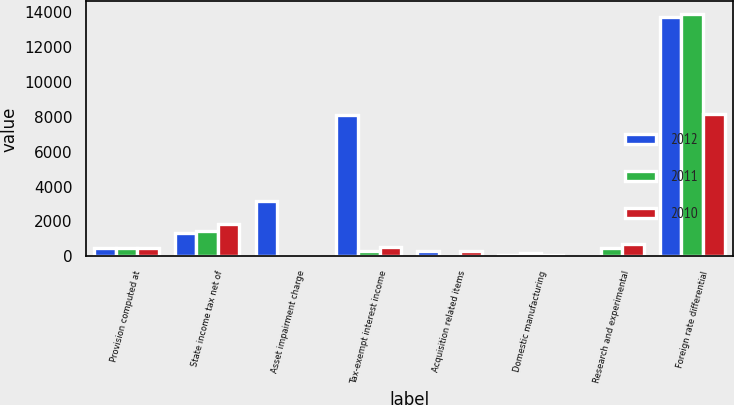<chart> <loc_0><loc_0><loc_500><loc_500><stacked_bar_chart><ecel><fcel>Provision computed at<fcel>State income tax net of<fcel>Asset impairment charge<fcel>Tax-exempt interest income<fcel>Acquisition related items<fcel>Domestic manufacturing<fcel>Research and experimental<fcel>Foreign rate differential<nl><fcel>2012<fcel>508<fcel>1353<fcel>3190<fcel>8118<fcel>322<fcel>105<fcel>0<fcel>13710<nl><fcel>2011<fcel>508<fcel>1432<fcel>0<fcel>334<fcel>0<fcel>212<fcel>508<fcel>13899<nl><fcel>2010<fcel>508<fcel>1884<fcel>0<fcel>554<fcel>315<fcel>70<fcel>713<fcel>8134<nl></chart> 